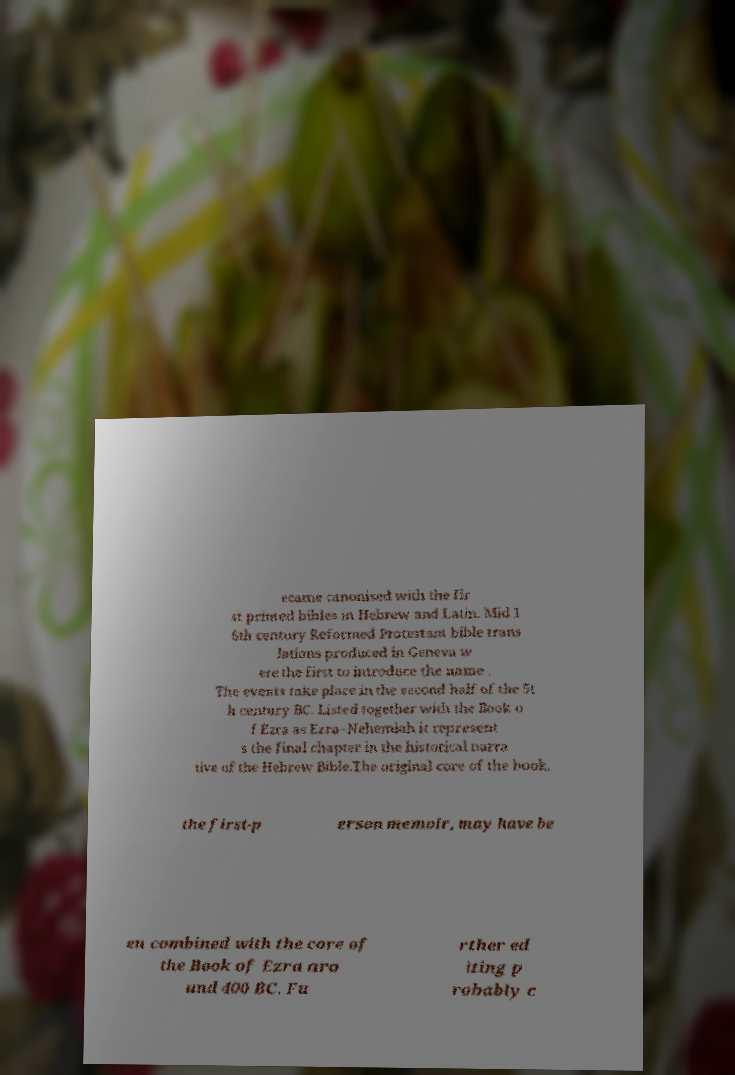Could you assist in decoding the text presented in this image and type it out clearly? ecame canonised with the fir st printed bibles in Hebrew and Latin. Mid 1 6th century Reformed Protestant bible trans lations produced in Geneva w ere the first to introduce the name . The events take place in the second half of the 5t h century BC. Listed together with the Book o f Ezra as Ezra–Nehemiah it represent s the final chapter in the historical narra tive of the Hebrew Bible.The original core of the book, the first-p erson memoir, may have be en combined with the core of the Book of Ezra aro und 400 BC. Fu rther ed iting p robably c 